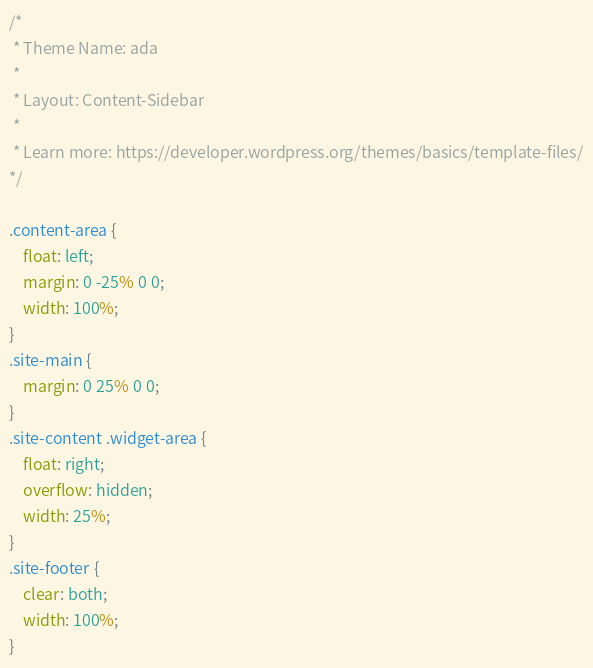<code> <loc_0><loc_0><loc_500><loc_500><_CSS_>/*
 * Theme Name: ada
 *
 * Layout: Content-Sidebar
 *
 * Learn more: https://developer.wordpress.org/themes/basics/template-files/
*/

.content-area {
	float: left;
	margin: 0 -25% 0 0;
	width: 100%;
}
.site-main {
	margin: 0 25% 0 0;
}
.site-content .widget-area {
	float: right;
	overflow: hidden;
	width: 25%;
}
.site-footer {
	clear: both;
	width: 100%;
}</code> 